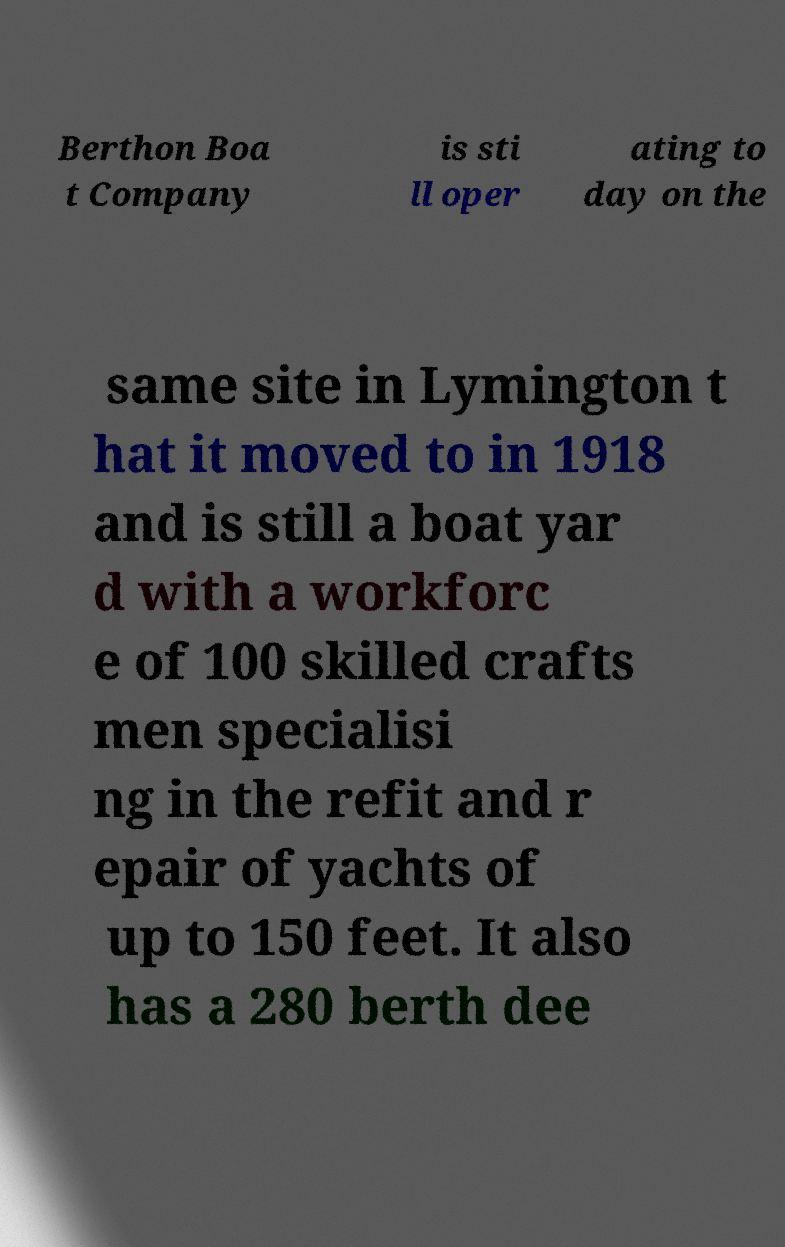Can you read and provide the text displayed in the image?This photo seems to have some interesting text. Can you extract and type it out for me? Berthon Boa t Company is sti ll oper ating to day on the same site in Lymington t hat it moved to in 1918 and is still a boat yar d with a workforc e of 100 skilled crafts men specialisi ng in the refit and r epair of yachts of up to 150 feet. It also has a 280 berth dee 